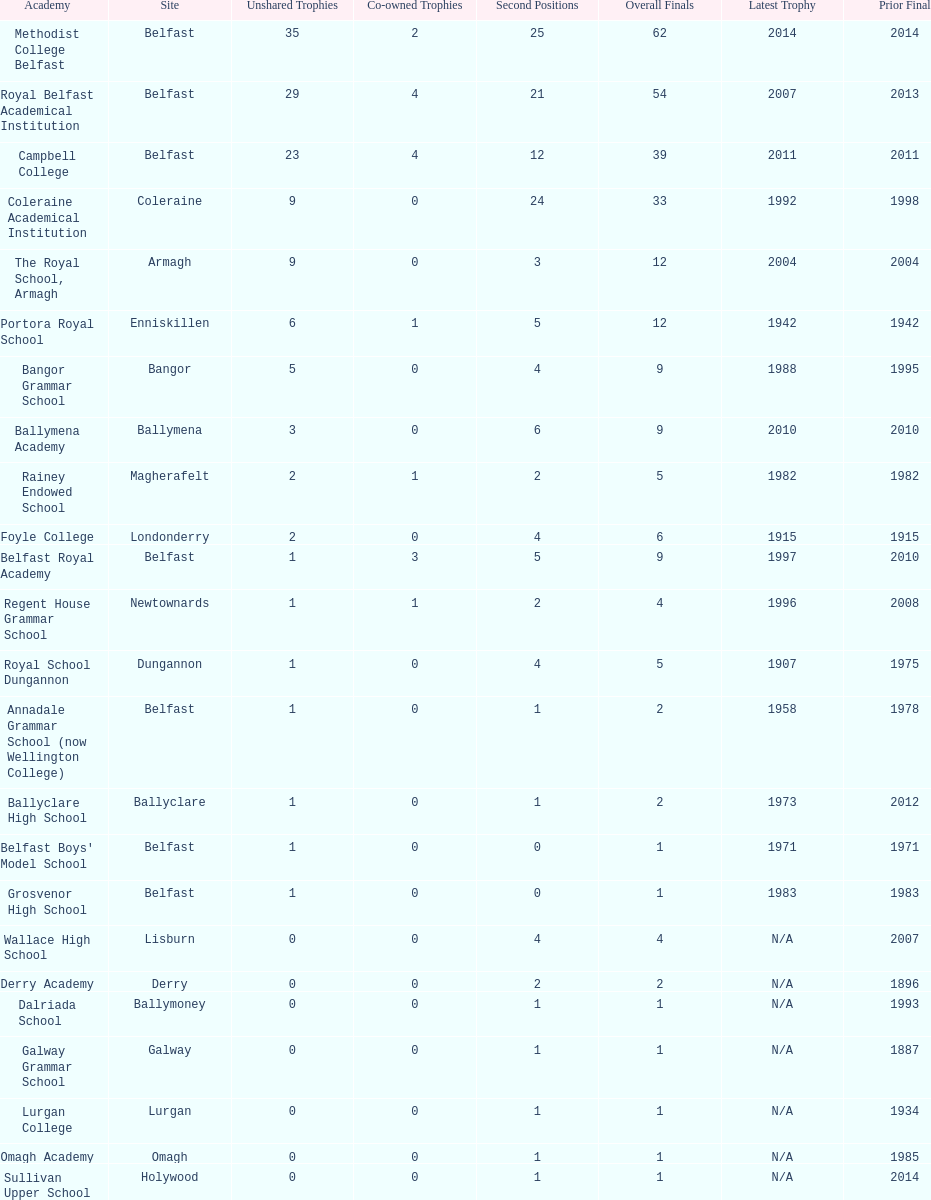How many schools have at least 5 outright titles? 7. 